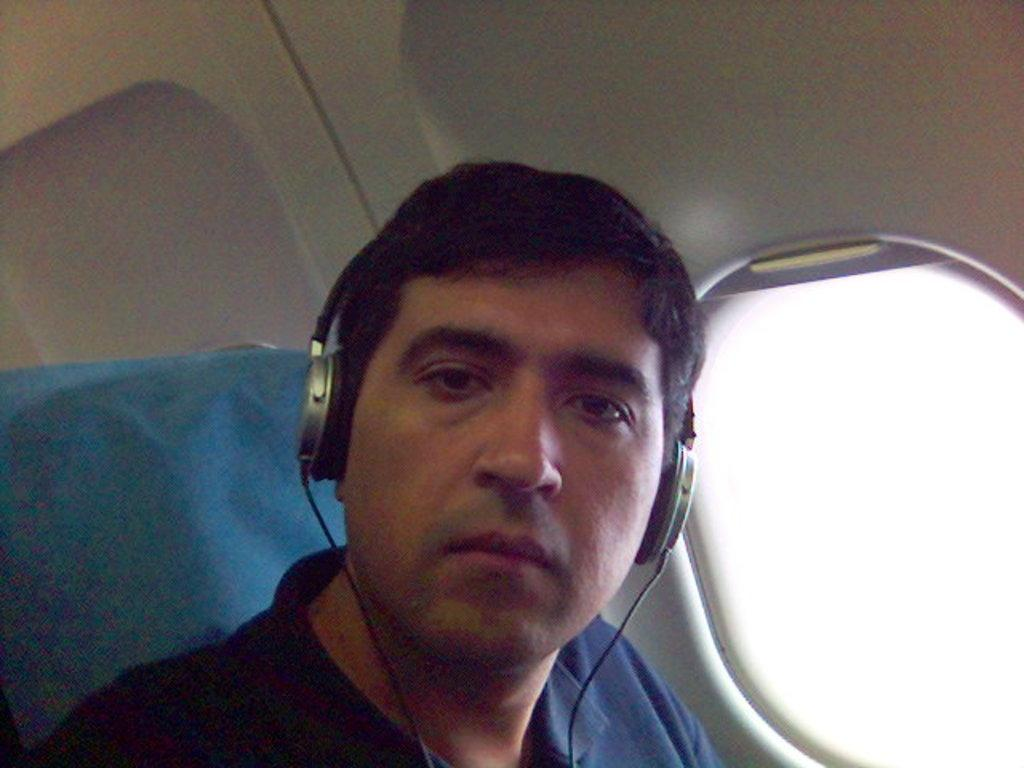What is the main subject of the image? There is a man in the image. What is the man wearing? The man is wearing a blue t-shirt. What is the man doing in the image? The man is sitting in a flight. What is the man's facial expression or action in the image? The man is looking into the camera. What can be seen in the background of the image? There is a flight cabin visible in the image. What is visible through the window in the image? There is a window in the image. What type of flesh can be seen growing on the man's arm in the image? There is no flesh or growth visible on the man's arm in the image. What type of curve is present in the man's posture in the image? The man's posture in the image does not show any specific curve. 